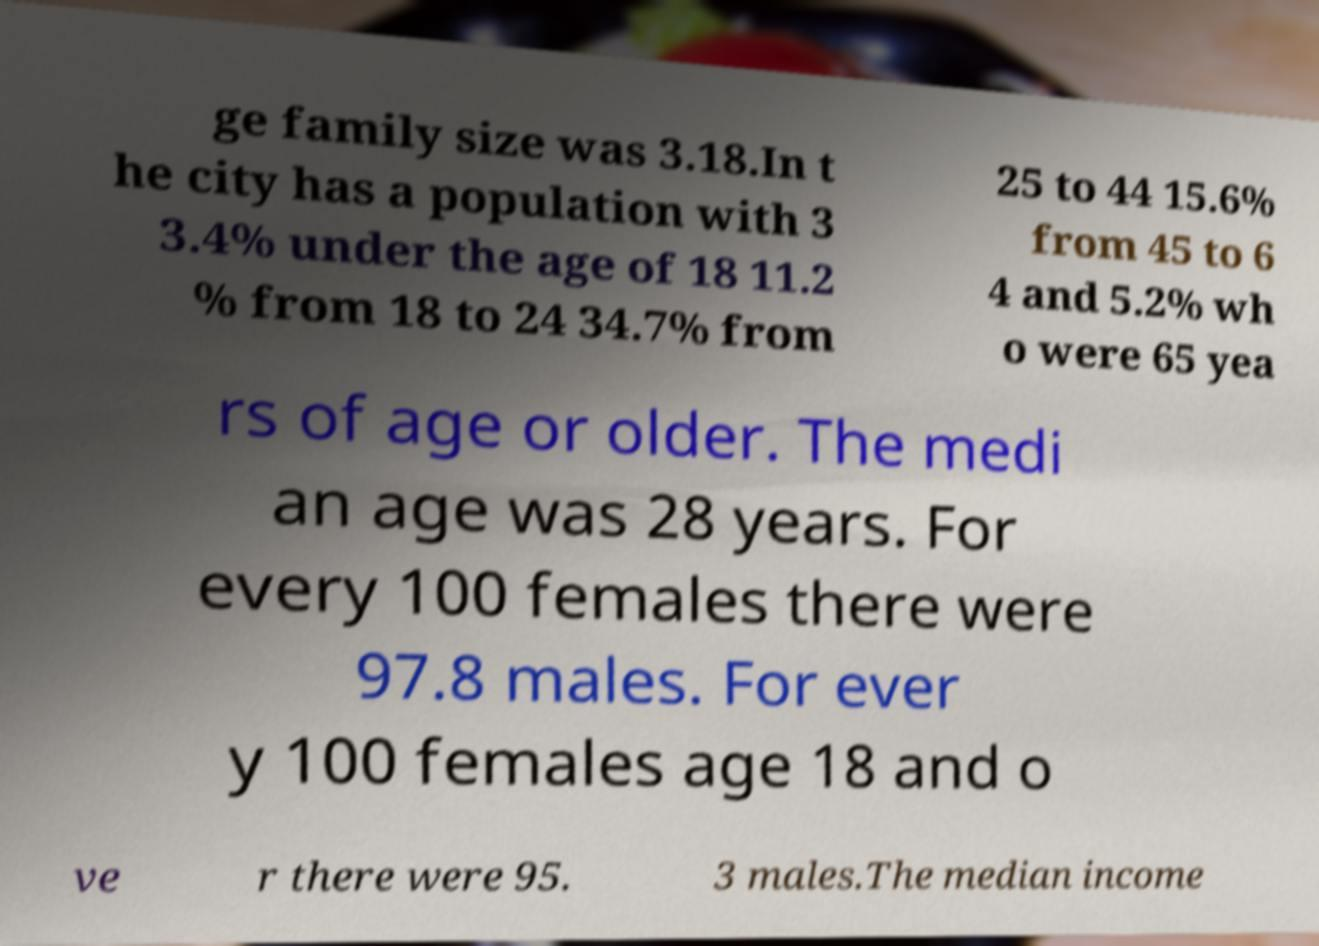There's text embedded in this image that I need extracted. Can you transcribe it verbatim? ge family size was 3.18.In t he city has a population with 3 3.4% under the age of 18 11.2 % from 18 to 24 34.7% from 25 to 44 15.6% from 45 to 6 4 and 5.2% wh o were 65 yea rs of age or older. The medi an age was 28 years. For every 100 females there were 97.8 males. For ever y 100 females age 18 and o ve r there were 95. 3 males.The median income 